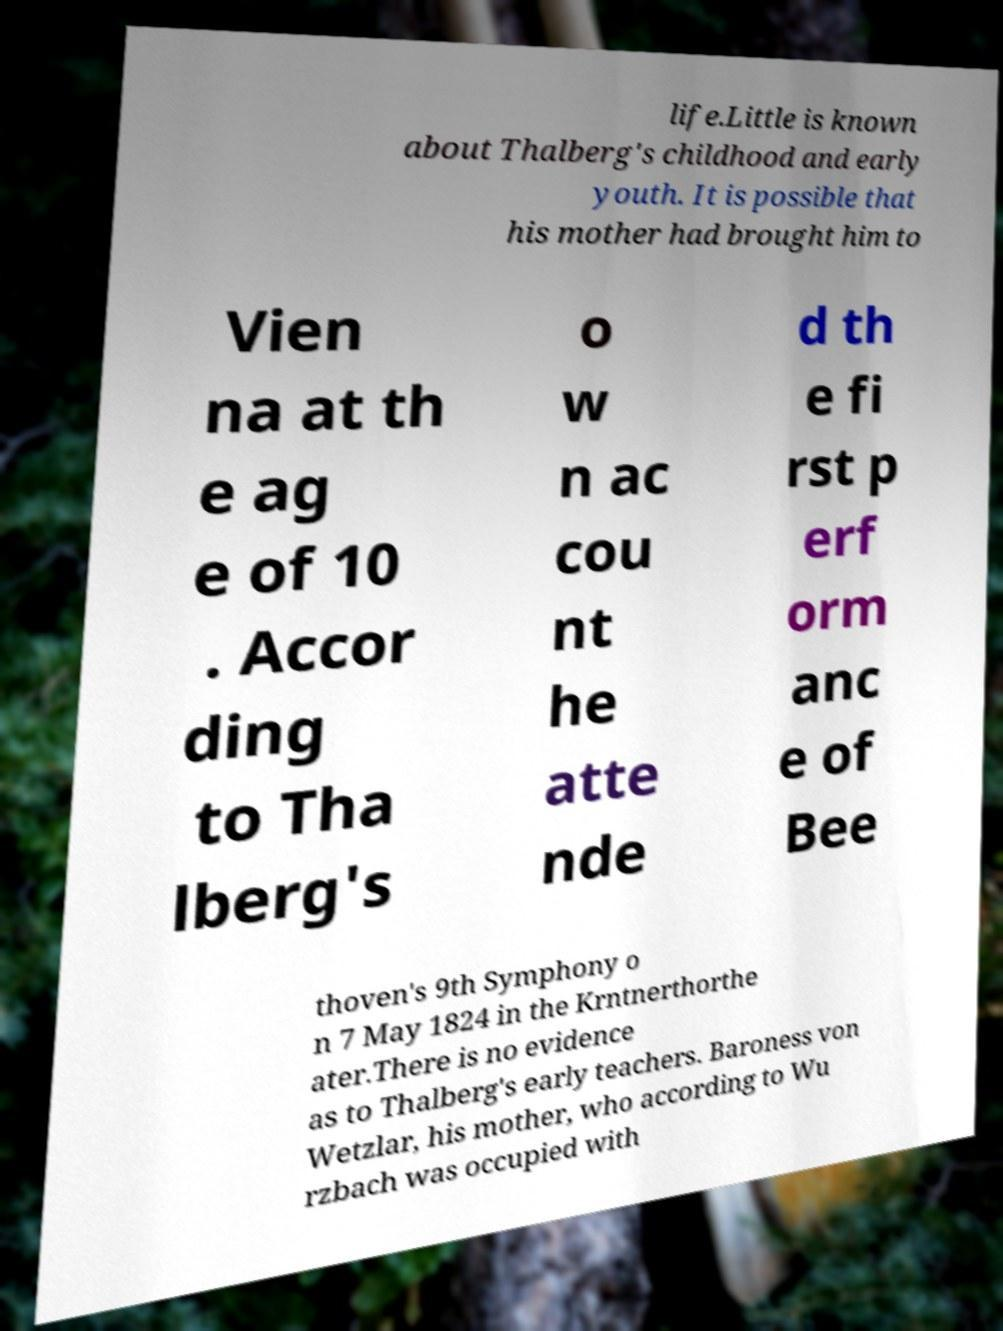What messages or text are displayed in this image? I need them in a readable, typed format. life.Little is known about Thalberg's childhood and early youth. It is possible that his mother had brought him to Vien na at th e ag e of 10 . Accor ding to Tha lberg's o w n ac cou nt he atte nde d th e fi rst p erf orm anc e of Bee thoven's 9th Symphony o n 7 May 1824 in the Krntnerthorthe ater.There is no evidence as to Thalberg's early teachers. Baroness von Wetzlar, his mother, who according to Wu rzbach was occupied with 